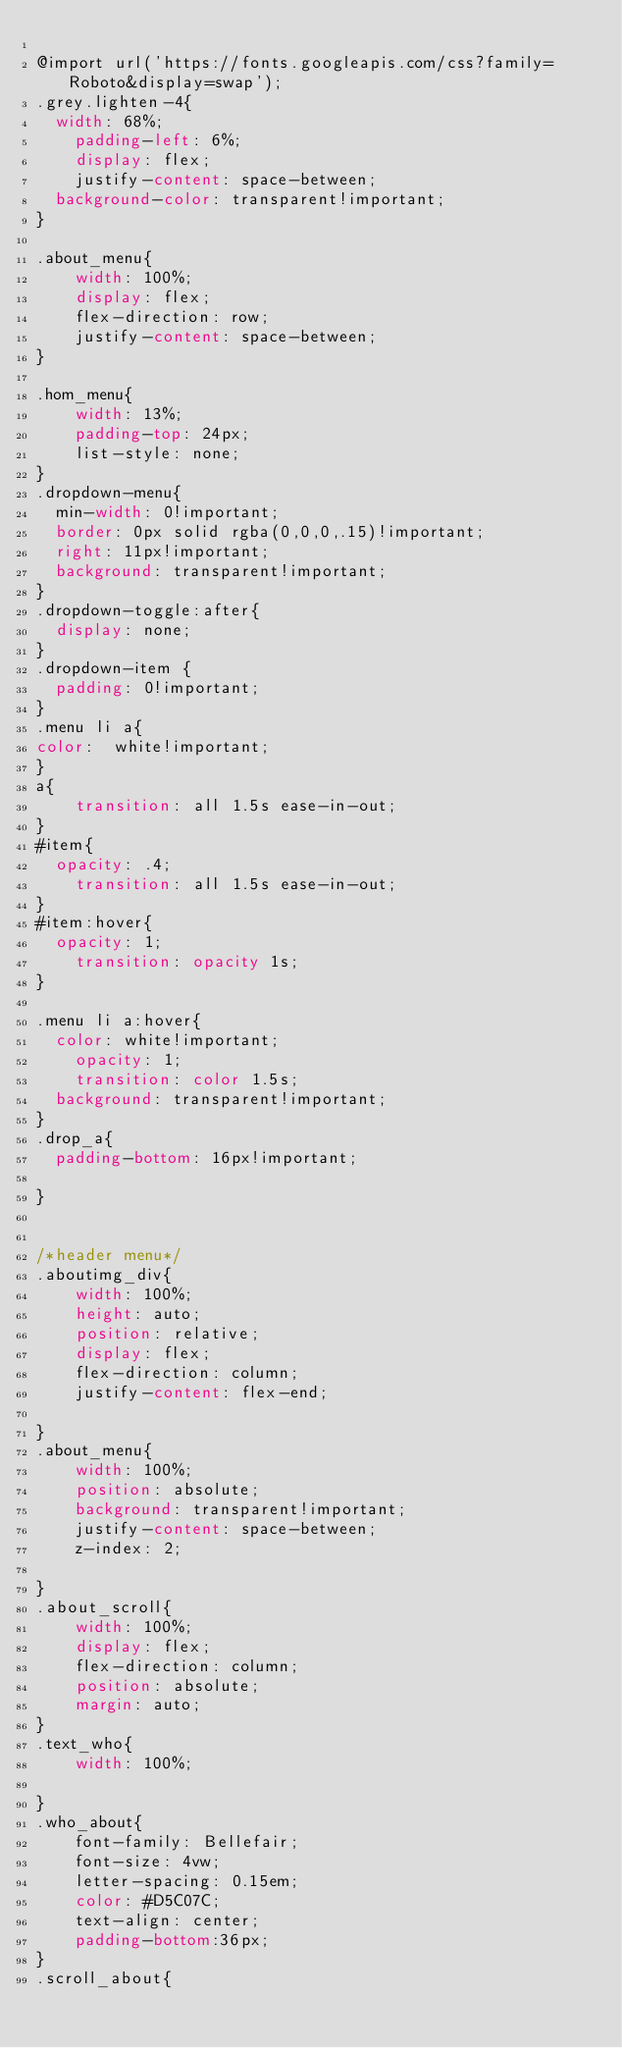Convert code to text. <code><loc_0><loc_0><loc_500><loc_500><_CSS_>
@import url('https://fonts.googleapis.com/css?family=Roboto&display=swap');
.grey.lighten-4{
	width: 68%;
    padding-left: 6%;
    display: flex;
    justify-content: space-between;
	background-color: transparent!important;
} 

.about_menu{
    width: 100%;
    display: flex;
    flex-direction: row;
    justify-content: space-between;
}

.hom_menu{
    width: 13%;
    padding-top: 24px;
    list-style: none;
}
.dropdown-menu{
	min-width: 0!important;
	border: 0px solid rgba(0,0,0,.15)!important;
	right: 11px!important;
	background: transparent!important;
}
.dropdown-toggle:after{
	display: none;
}
.dropdown-item {
	padding: 0!important;
}
.menu li a{
color: 	white!important;
}
a{
    transition: all 1.5s ease-in-out;
}
#item{
	opacity: .4;
    transition: all 1.5s ease-in-out;
}
#item:hover{
	opacity: 1;
    transition: opacity 1s;
}

.menu li a:hover{
	color: white!important;
    opacity: 1;
    transition: color 1.5s;
	background: transparent!important;
}
.drop_a{
	padding-bottom: 16px!important;
	
}


/*header menu*/
.aboutimg_div{
    width: 100%;
    height: auto;
    position: relative;
    display: flex;
    flex-direction: column;
    justify-content: flex-end;
    
}
.about_menu{
    width: 100%;
    position: absolute;
    background: transparent!important;
    justify-content: space-between;
    z-index: 2;
   
}
.about_scroll{
    width: 100%;
    display: flex;
    flex-direction: column;
    position: absolute;
    margin: auto;
}
.text_who{
    width: 100%;
   
}
.who_about{
    font-family: Bellefair;
    font-size: 4vw;
    letter-spacing: 0.15em;
    color: #D5C07C;
    text-align: center;
    padding-bottom:36px;
}
.scroll_about{</code> 